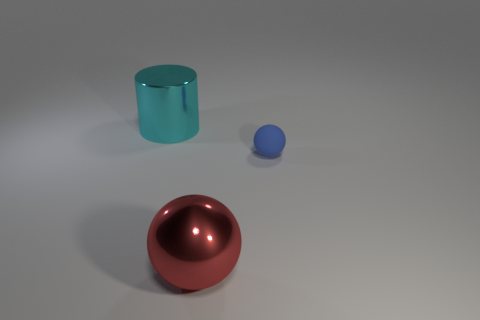Add 1 green shiny spheres. How many objects exist? 4 Subtract all cylinders. How many objects are left? 2 Subtract all small blue rubber balls. Subtract all cyan objects. How many objects are left? 1 Add 3 big red objects. How many big red objects are left? 4 Add 3 big red metal objects. How many big red metal objects exist? 4 Subtract 0 purple blocks. How many objects are left? 3 